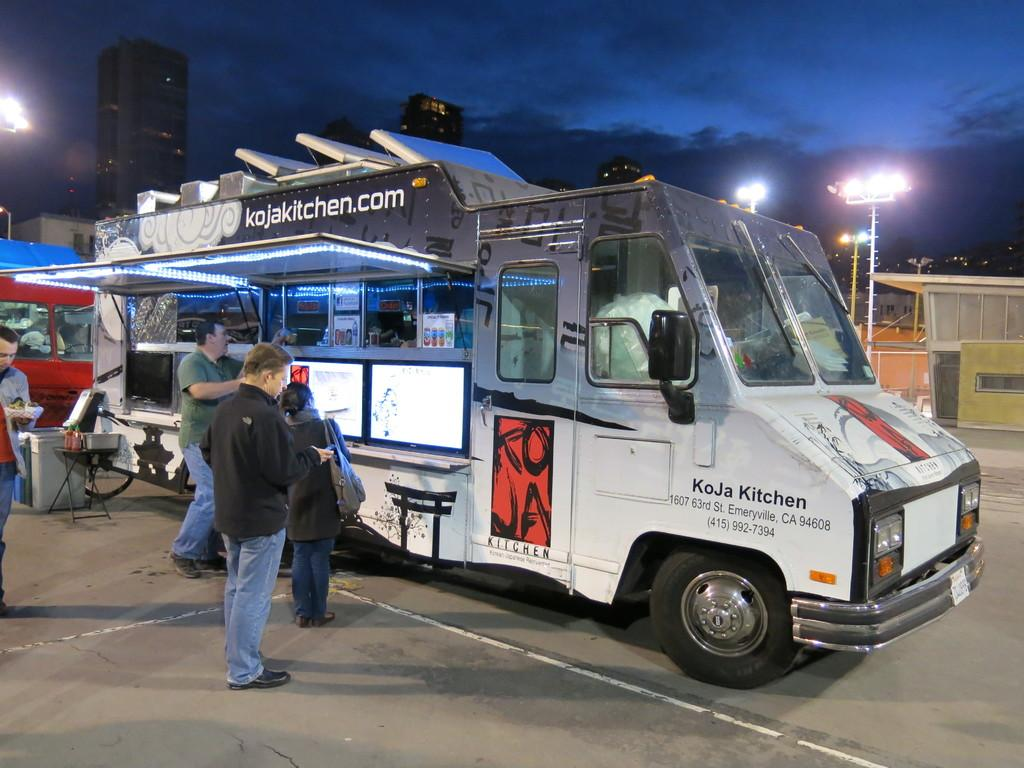<image>
Provide a brief description of the given image. People  in line to get food from the KoJa Kitchen food truck at night. 